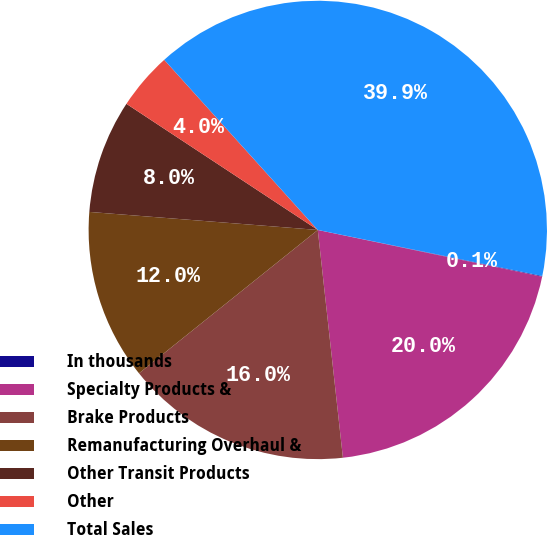<chart> <loc_0><loc_0><loc_500><loc_500><pie_chart><fcel>In thousands<fcel>Specialty Products &<fcel>Brake Products<fcel>Remanufacturing Overhaul &<fcel>Other Transit Products<fcel>Other<fcel>Total Sales<nl><fcel>0.05%<fcel>19.98%<fcel>15.99%<fcel>12.01%<fcel>8.02%<fcel>4.04%<fcel>39.9%<nl></chart> 